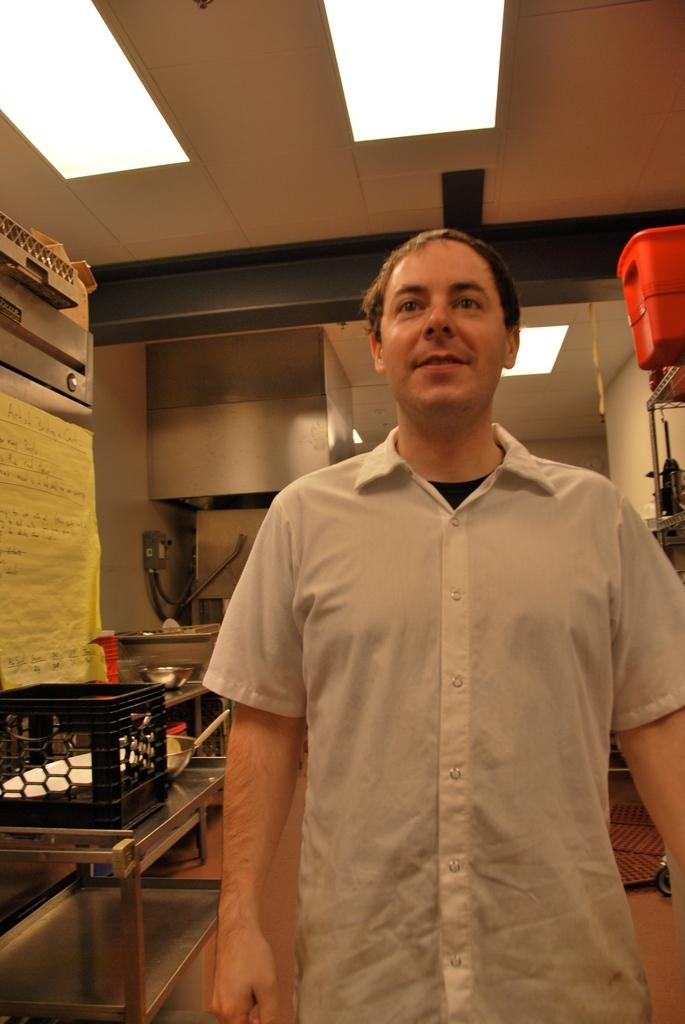What is the main subject of the image? There is a man in the image. What is the man doing in the image? The man is standing and smiling. What can be seen in the background of the image? There are equipment and lights on the ceiling in the background of the image. Can you see a kite being flown by the man in the image? There is no kite present in the image. Is the man in the image a fireman? The image does not provide any information about the man's occupation, so we cannot determine if he is a fireman. 